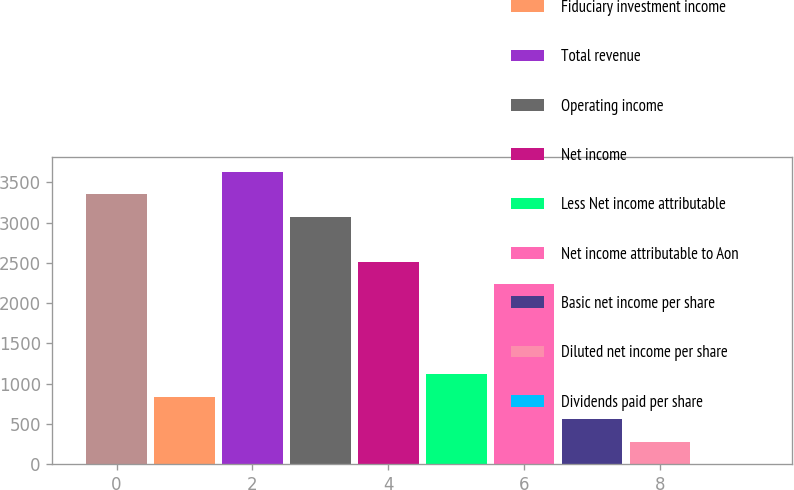<chart> <loc_0><loc_0><loc_500><loc_500><bar_chart><fcel>Commissions fees and other<fcel>Fiduciary investment income<fcel>Total revenue<fcel>Operating income<fcel>Net income<fcel>Less Net income attributable<fcel>Net income attributable to Aon<fcel>Basic net income per share<fcel>Diluted net income per share<fcel>Dividends paid per share<nl><fcel>3352.74<fcel>838.32<fcel>3632.12<fcel>3073.36<fcel>2514.6<fcel>1117.7<fcel>2235.22<fcel>558.94<fcel>279.56<fcel>0.18<nl></chart> 